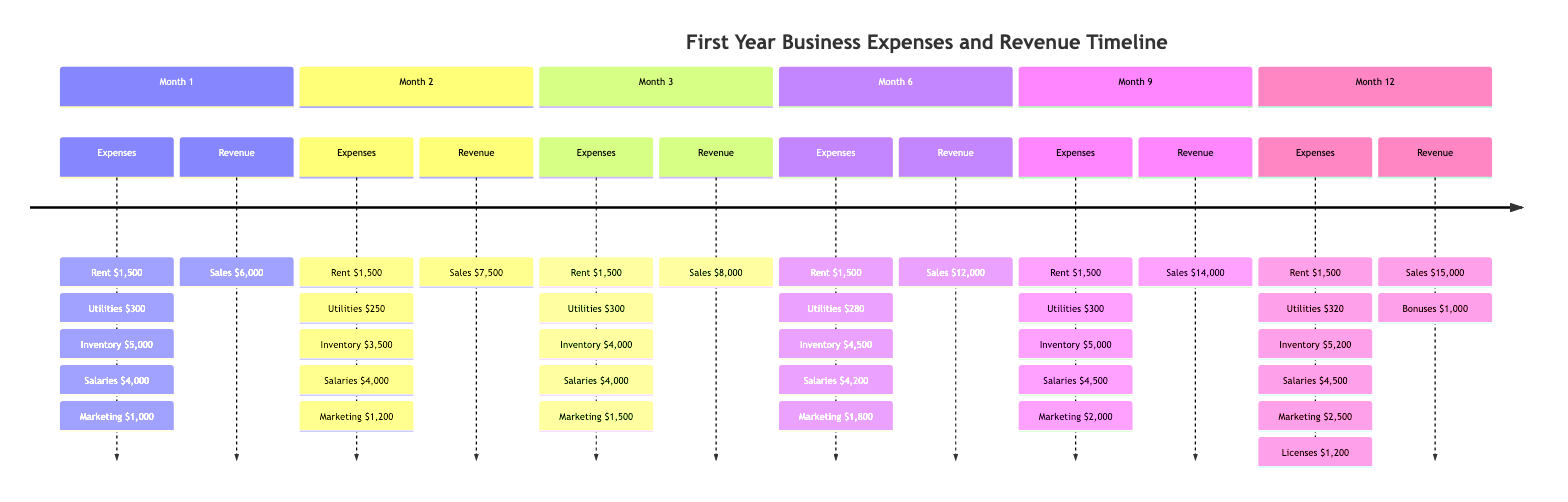What were the total expenses for Month 1? To find the total expenses for Month 1, we need to sum up the values of all expense categories: Rent ($1,500) + Utilities ($300) + Inventory Purchase ($5,000) + Employee Salaries ($4,000) + Marketing ($1,000). This gives us a total of $1,500 + $300 + $5,000 + $4,000 + $1,000 = $11,800.
Answer: $11,800 What was the revenue in Month 9? The revenue for Month 9 is specified under the Revenue section as Sales. Checking the values, we see that the sales amount for Month 9 is $14,000.
Answer: $14,000 Which month had the highest expenses? To determine which month had the highest expenses, we need to calculate the total expenses for each month and compare them. Through calculations, Month 12 has the highest total at $15,320 (considering the additional annual licenses and fees).
Answer: Month 12 How much did marketing expenses increase from Month 1 to Month 12? We find the marketing expense for Month 1, which is $1,000, and for Month 12, which is $2,500. The increase is calculated by subtracting the Month 1 marketing expense from Month 12's: $2,500 - $1,000 = $1,500.
Answer: $1,500 What is the difference between total revenues in Month 6 and Month 3? The total revenue for Month 6 is $12,000, and for Month 3, it is $8,000. The difference is calculated by subtracting Month 3's revenue from Month 6's: $12,000 - $8,000 = $4,000.
Answer: $4,000 In which month did the highest sales occur? The timeline shows that Month 12 has the highest revenue, which includes sales of $15,000. By checking all months, Month 12 has the highest sales figure.
Answer: Month 12 How much were the employee salaries in Month 6? In Month 6, the employee salaries are specified in the Expenses section as $4,200. Therefore, that is the salary amount for that month.
Answer: $4,200 Which month had the lowest utility expenses? To identify the month with the lowest utility expenses, we examine the utility costs: Month 1 ($300), Month 2 ($250), Month 3 ($300), Month 6 ($280), Month 9 ($300), Month 12 ($320). The lowest recorded utility expense is in Month 2 at $250.
Answer: Month 2 